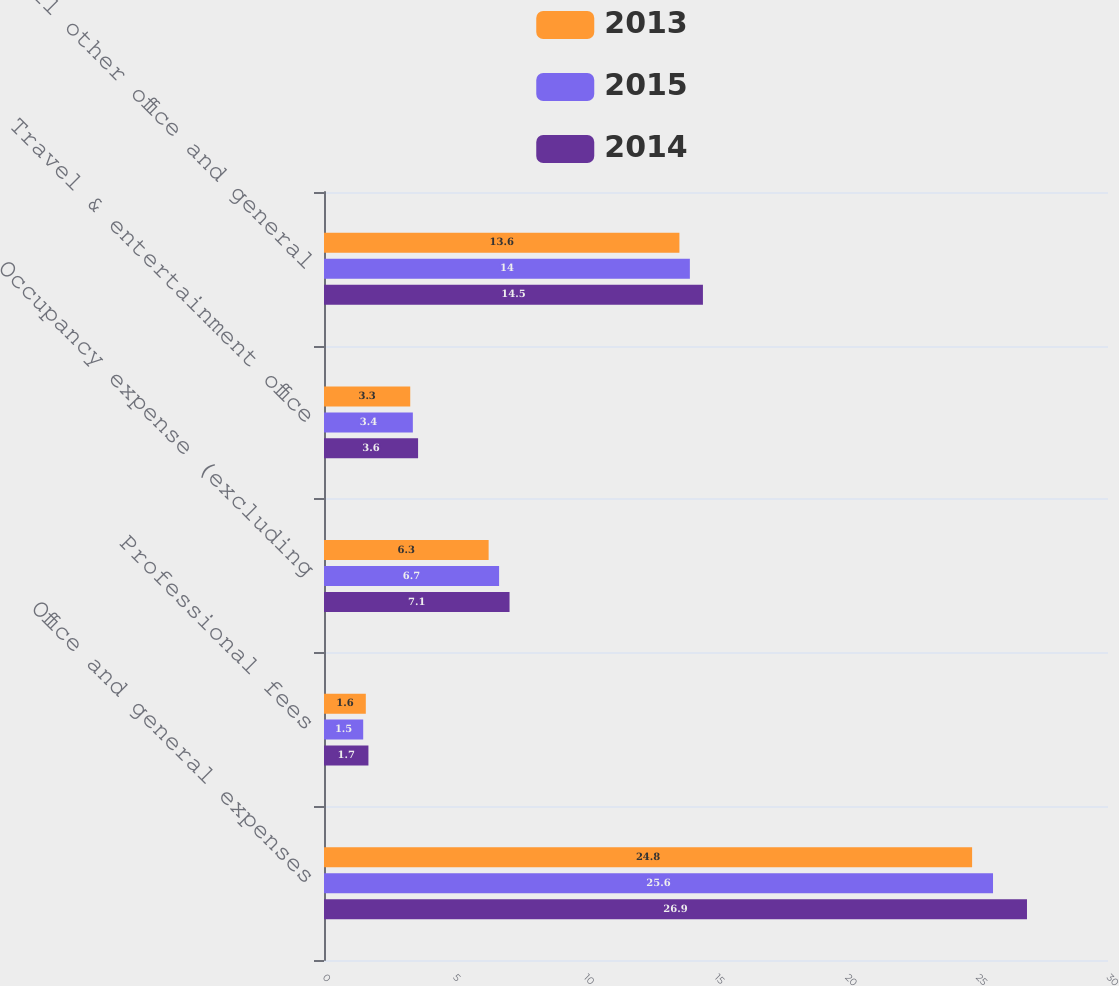<chart> <loc_0><loc_0><loc_500><loc_500><stacked_bar_chart><ecel><fcel>Office and general expenses<fcel>Professional fees<fcel>Occupancy expense (excluding<fcel>Travel & entertainment office<fcel>All other office and general<nl><fcel>2013<fcel>24.8<fcel>1.6<fcel>6.3<fcel>3.3<fcel>13.6<nl><fcel>2015<fcel>25.6<fcel>1.5<fcel>6.7<fcel>3.4<fcel>14<nl><fcel>2014<fcel>26.9<fcel>1.7<fcel>7.1<fcel>3.6<fcel>14.5<nl></chart> 